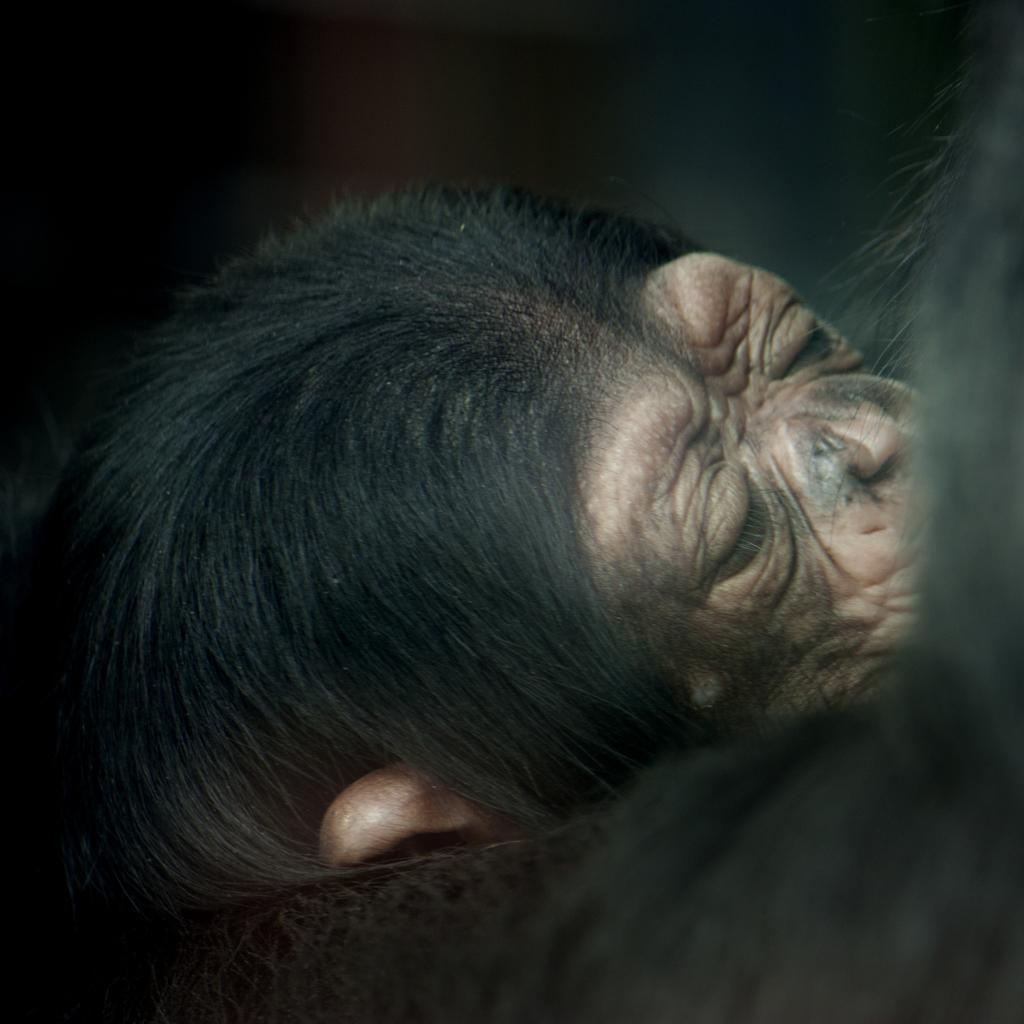What type of creature is in the image? There is an animal in the image. Can you describe the colors of the animal? The animal has black and brown colors. What is the color of the background in the image? The background of the image is black. What type of writing can be seen on the animal's fur in the image? There is no writing visible on the animal's fur in the image. Can you see any magical elements in the image? There are no magical elements present in the image. 